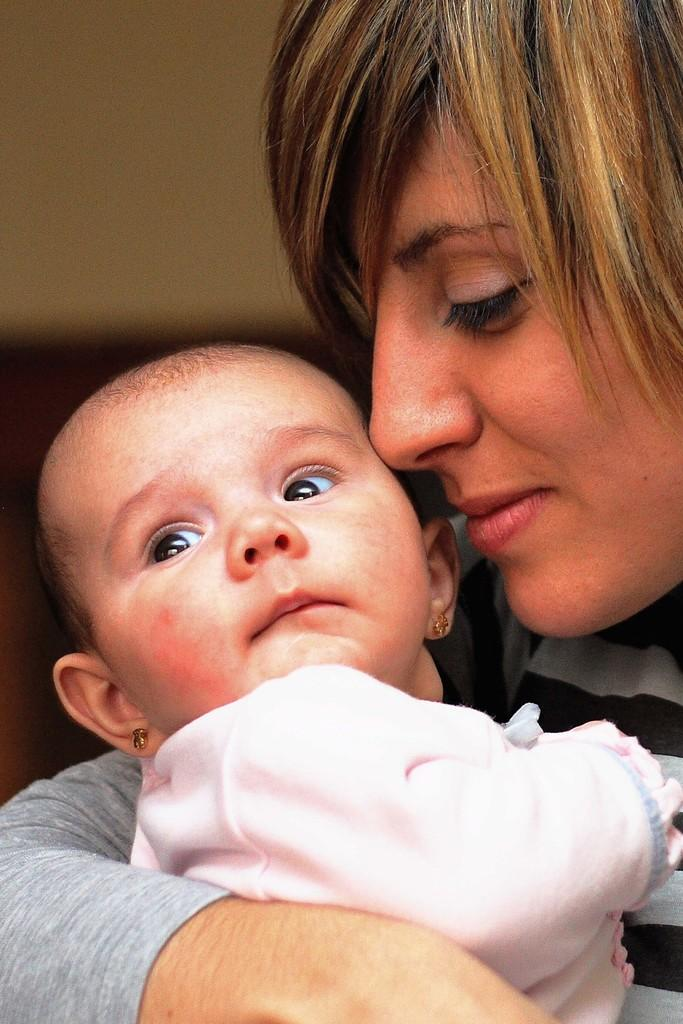Who is the main subject in the image? There is a woman in the image. What is the woman doing in the image? The woman is holding a baby. What are the woman and the baby wearing? Both the woman and the baby are wearing dresses. What type of pet can be seen playing with the baby in the image? There is no pet present in the image, and the baby is not shown playing with any animals. 